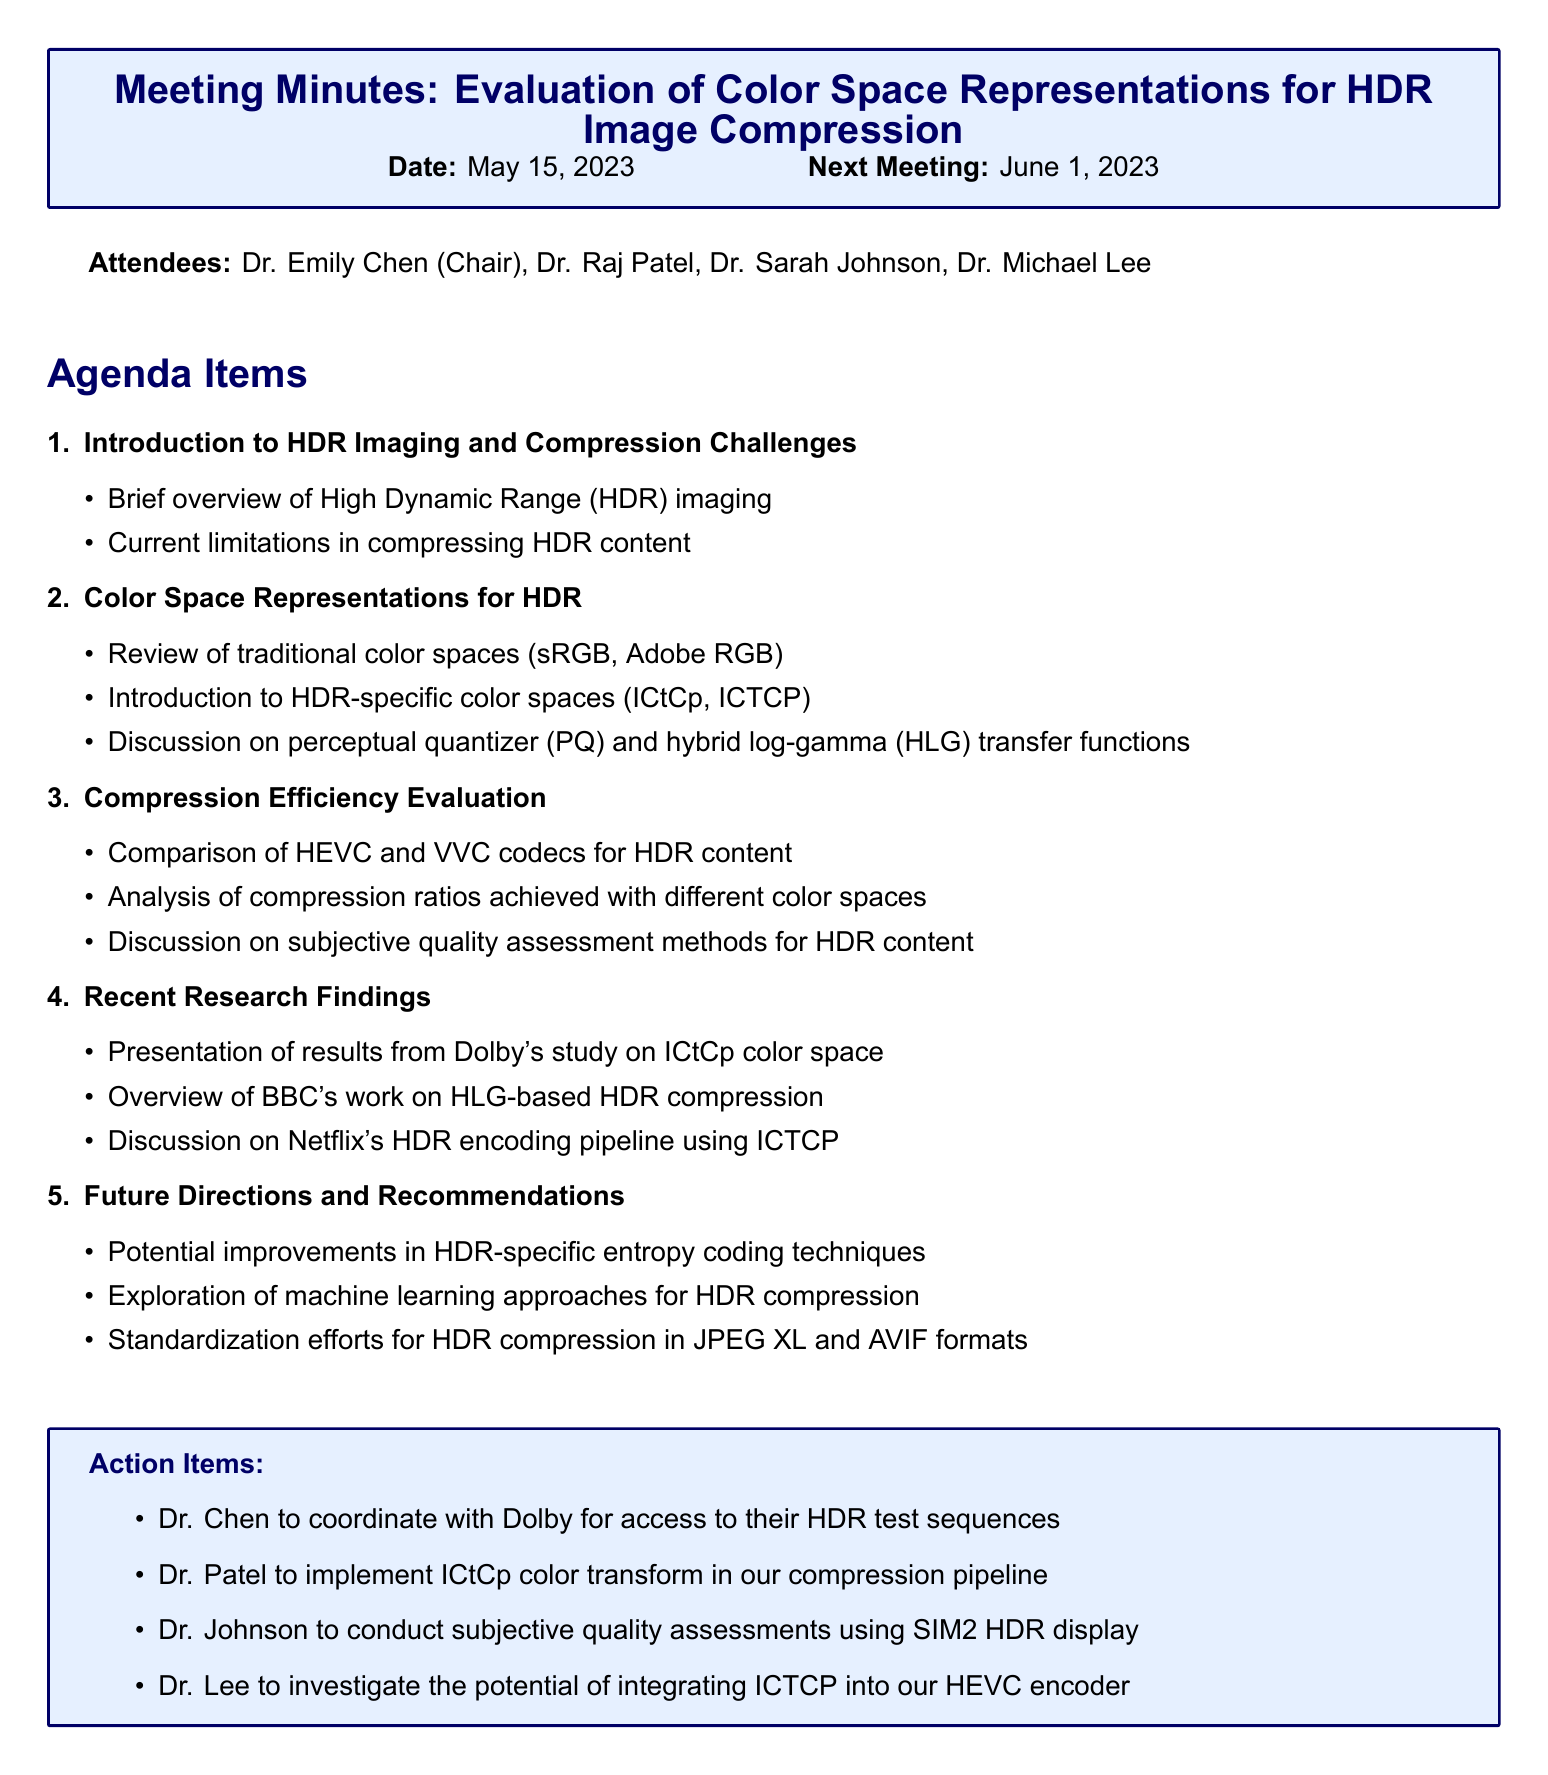What is the meeting title? The meeting title is explicitly stated at the beginning of the document.
Answer: Evaluation of Color Space Representations for HDR Image Compression Who chaired the meeting? The chairperson of the meeting is listed among the attendees.
Answer: Dr. Emily Chen What color space was presented from Dolby's study? The results from Dolby's study focus on a specific color space mentioned in the agenda.
Answer: ICtCp When is the next meeting scheduled? The date of the next meeting is specified at the beginning of the document.
Answer: June 1, 2023 Which two codecs were compared for HDR content? The comparison of codecs is mentioned under the "Compression Efficiency Evaluation" section.
Answer: HEVC and VVC What is one of the action items for Dr. Patel? Dr. Patel's specific responsibilities are listed under the action items section.
Answer: Implement ICtCp color transform in our compression pipeline What technique is mentioned for potential improvement in HDR-specific coding? The future directions section discusses potential techniques for improvement.
Answer: Entropy coding techniques How many agenda items were discussed in total? The number of agenda items can be counted from the document structure.
Answer: Five 